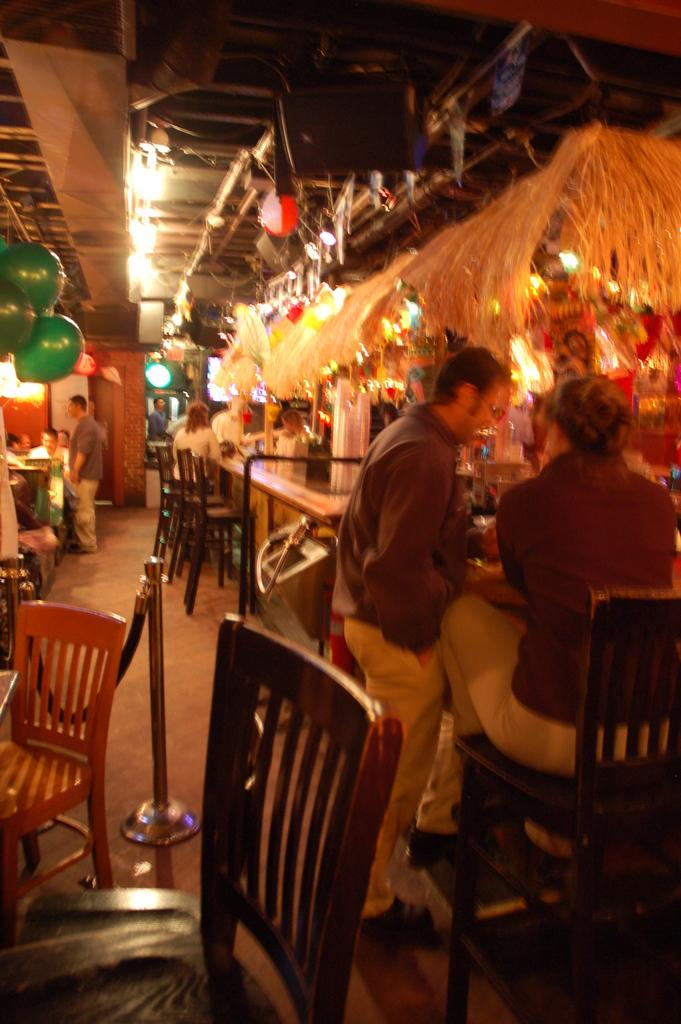How many people are in the image? There are two persons in the right corner of the image. What is located in front of the two persons? There is a store in front of the two persons. What can be seen in the left corner of the image? There are two empty chairs in the left corner of the image. Can you describe the background of the image? There are people visible in the background of the image. What type of receipt can be seen being handed out by the store in the image? There is no receipt visible in the image, nor is there any indication that a receipt is being handed out. 